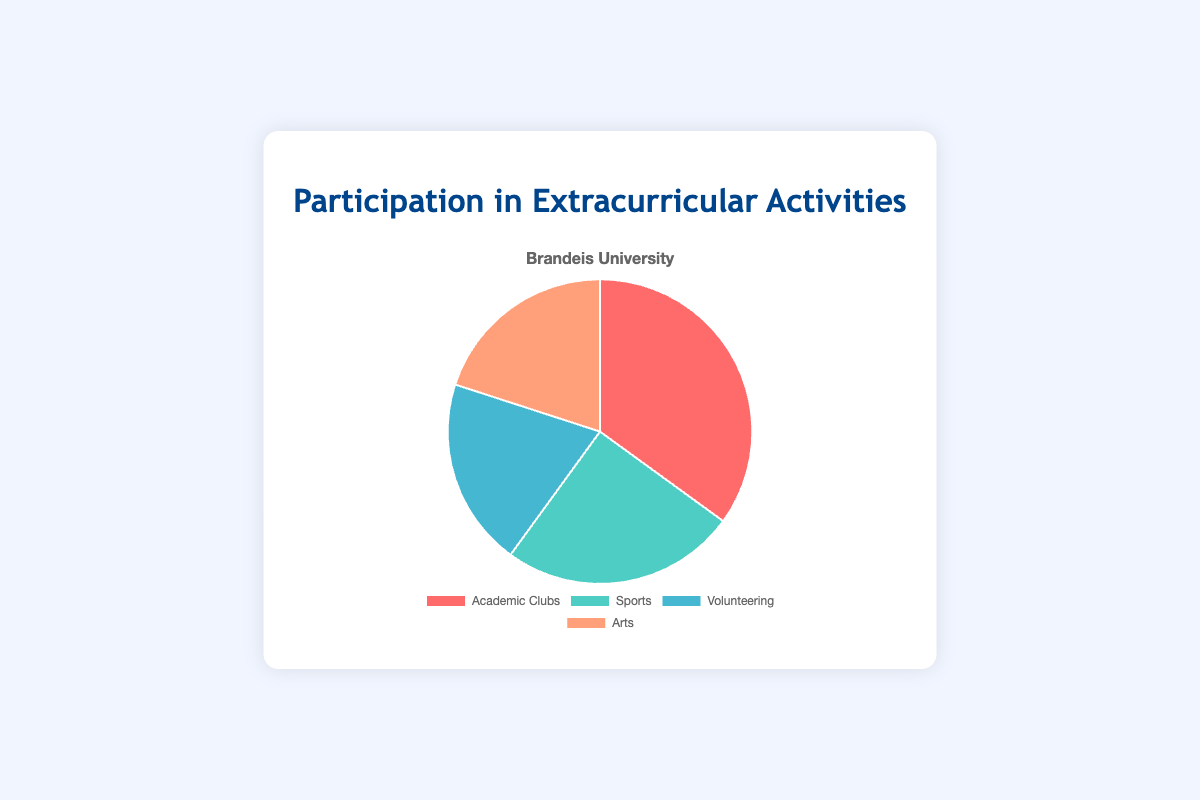What percentage of students participate in Sports? The total number of participants is 35+25+20+20=100. To find the percentage for Sports, divide the number of students in Sports (25) by the total number of participants and multiply by 100. 25/100 * 100 = 25%.
Answer: 25% Which category has the smallest participation? By looking at the given data points, both Volunteering and Arts have the smallest participation with 20 students each.
Answer: Volunteering and Arts What is the difference in participation between Academic Clubs and Sports? The participation in Academic Clubs is 35, and participation in Sports is 25. Subtracting the two gives 35 - 25 = 10.
Answer: 10 What is the combined participation percentage for Volunteering and Arts? The total number of participants is 100. The combined participation for Volunteering and Arts is 20 + 20 = 40. To find the percentage, divide 40 by 100 and multiply by 100. 40/100 * 100 = 40%.
Answer: 40% Which activity has the highest participation? By checking the participation numbers, Academic Clubs has the highest participation with 35 students.
Answer: Academic Clubs How much less is the participation in Volunteering compared to Academic Clubs? The participation in Academic Clubs is 35, and in Volunteering, it is 20. The difference is 35 - 20 = 15.
Answer: 15 What fraction of the total participation is in Arts? The total number of participants is 100. The number of participants in Arts is 20. Therefore, the fraction is 20/100, which simplifies to 1/5.
Answer: 1/5 If an additional 10 students joined the Volunteering category, what would the new percentage for Volunteering be? The new number of participants in Volunteering would be 20+10=30. The new total number of participants would be 100+10=110. The new percentage for Volunteering would be (30/110) * 100 = 27.27%.
Answer: 27.27% 